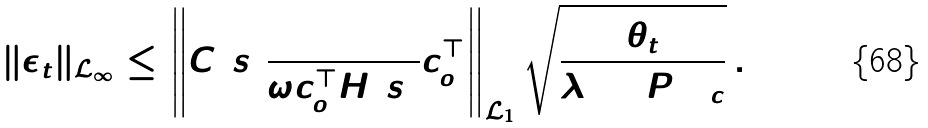Convert formula to latex. <formula><loc_0><loc_0><loc_500><loc_500>\| \epsilon _ { \bar { t } } \| _ { \mathcal { L } _ { \infty } } \leq \left \| C ( s ) \frac { 1 } { \omega c _ { o } ^ { \top } H ( s ) } c _ { o } ^ { \top } \right \| _ { \mathcal { L } _ { 1 } } \sqrt { \frac { \theta _ { \bar { t } } } { \lambda _ { \min } ( P ) \Gamma _ { c } } } \, .</formula> 